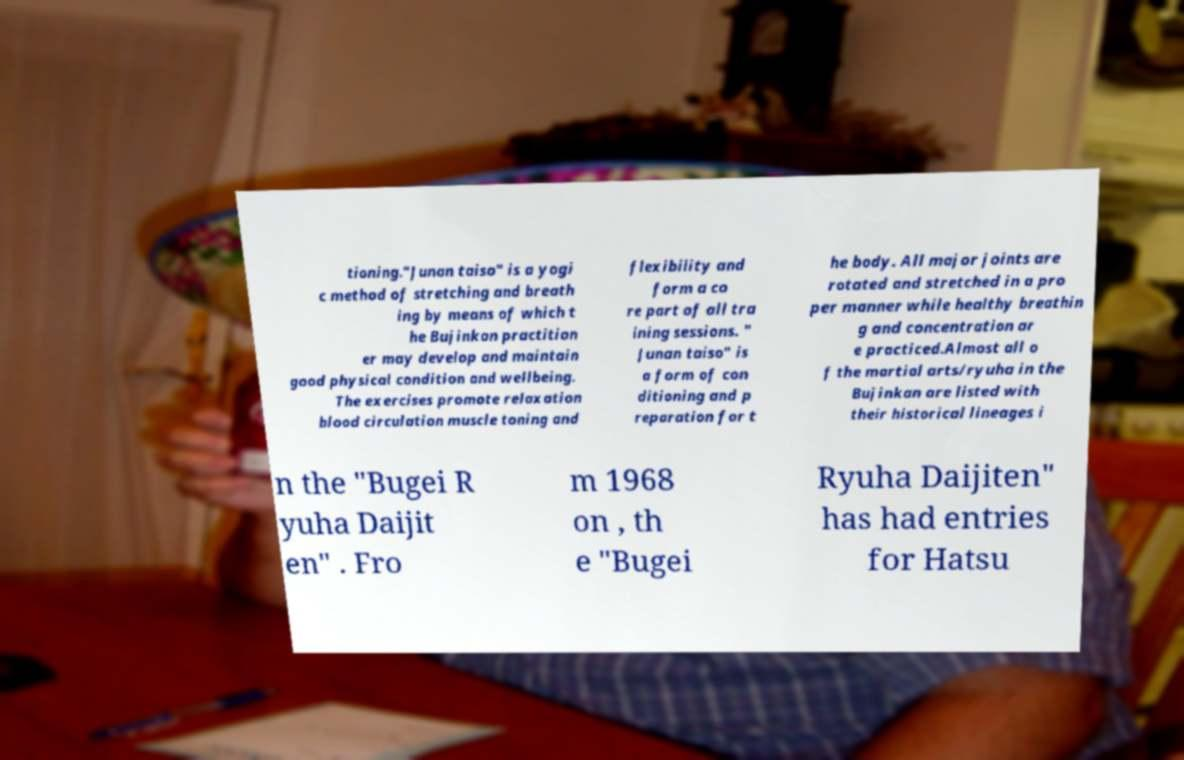Can you accurately transcribe the text from the provided image for me? tioning."Junan taiso" is a yogi c method of stretching and breath ing by means of which t he Bujinkan practition er may develop and maintain good physical condition and wellbeing. The exercises promote relaxation blood circulation muscle toning and flexibility and form a co re part of all tra ining sessions. " Junan taiso" is a form of con ditioning and p reparation for t he body. All major joints are rotated and stretched in a pro per manner while healthy breathin g and concentration ar e practiced.Almost all o f the martial arts/ryuha in the Bujinkan are listed with their historical lineages i n the "Bugei R yuha Daijit en" . Fro m 1968 on , th e "Bugei Ryuha Daijiten" has had entries for Hatsu 